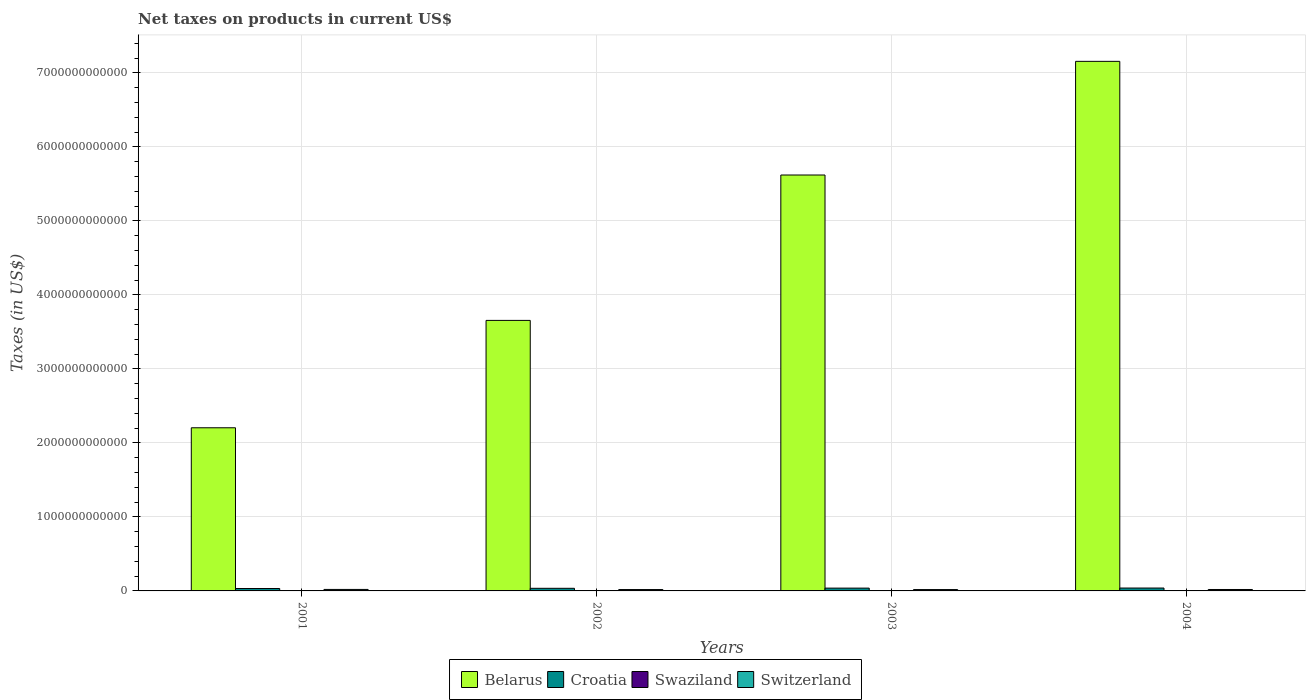How many different coloured bars are there?
Your answer should be compact. 4. Are the number of bars per tick equal to the number of legend labels?
Offer a very short reply. Yes. Are the number of bars on each tick of the X-axis equal?
Your answer should be very brief. Yes. How many bars are there on the 3rd tick from the left?
Keep it short and to the point. 4. In how many cases, is the number of bars for a given year not equal to the number of legend labels?
Ensure brevity in your answer.  0. What is the net taxes on products in Swaziland in 2002?
Provide a short and direct response. 2.25e+09. Across all years, what is the maximum net taxes on products in Belarus?
Your response must be concise. 7.16e+12. Across all years, what is the minimum net taxes on products in Switzerland?
Provide a succinct answer. 1.82e+1. What is the total net taxes on products in Croatia in the graph?
Provide a short and direct response. 1.45e+11. What is the difference between the net taxes on products in Belarus in 2001 and that in 2003?
Offer a terse response. -3.42e+12. What is the difference between the net taxes on products in Switzerland in 2003 and the net taxes on products in Croatia in 2002?
Your answer should be compact. -1.72e+1. What is the average net taxes on products in Swaziland per year?
Your answer should be compact. 2.58e+09. In the year 2003, what is the difference between the net taxes on products in Croatia and net taxes on products in Belarus?
Your answer should be compact. -5.58e+12. What is the ratio of the net taxes on products in Swaziland in 2001 to that in 2004?
Ensure brevity in your answer.  0.6. What is the difference between the highest and the second highest net taxes on products in Croatia?
Keep it short and to the point. 9.82e+08. What is the difference between the highest and the lowest net taxes on products in Swaziland?
Your response must be concise. 1.40e+09. In how many years, is the net taxes on products in Swaziland greater than the average net taxes on products in Swaziland taken over all years?
Provide a short and direct response. 1. Is it the case that in every year, the sum of the net taxes on products in Croatia and net taxes on products in Switzerland is greater than the sum of net taxes on products in Swaziland and net taxes on products in Belarus?
Ensure brevity in your answer.  No. What does the 1st bar from the left in 2001 represents?
Your answer should be very brief. Belarus. What does the 2nd bar from the right in 2003 represents?
Provide a succinct answer. Swaziland. Are all the bars in the graph horizontal?
Your answer should be compact. No. What is the difference between two consecutive major ticks on the Y-axis?
Make the answer very short. 1.00e+12. Are the values on the major ticks of Y-axis written in scientific E-notation?
Make the answer very short. No. Does the graph contain any zero values?
Your response must be concise. No. Does the graph contain grids?
Give a very brief answer. Yes. How many legend labels are there?
Offer a terse response. 4. What is the title of the graph?
Provide a succinct answer. Net taxes on products in current US$. What is the label or title of the X-axis?
Offer a very short reply. Years. What is the label or title of the Y-axis?
Your answer should be very brief. Taxes (in US$). What is the Taxes (in US$) in Belarus in 2001?
Make the answer very short. 2.20e+12. What is the Taxes (in US$) in Croatia in 2001?
Provide a succinct answer. 3.26e+1. What is the Taxes (in US$) of Swaziland in 2001?
Make the answer very short. 2.05e+09. What is the Taxes (in US$) in Switzerland in 2001?
Offer a very short reply. 2.01e+1. What is the Taxes (in US$) in Belarus in 2002?
Make the answer very short. 3.66e+12. What is the Taxes (in US$) of Croatia in 2002?
Your response must be concise. 3.54e+1. What is the Taxes (in US$) in Swaziland in 2002?
Ensure brevity in your answer.  2.25e+09. What is the Taxes (in US$) of Switzerland in 2002?
Offer a terse response. 1.84e+1. What is the Taxes (in US$) in Belarus in 2003?
Give a very brief answer. 5.62e+12. What is the Taxes (in US$) of Croatia in 2003?
Provide a succinct answer. 3.79e+1. What is the Taxes (in US$) in Swaziland in 2003?
Ensure brevity in your answer.  2.55e+09. What is the Taxes (in US$) in Switzerland in 2003?
Your response must be concise. 1.82e+1. What is the Taxes (in US$) in Belarus in 2004?
Offer a terse response. 7.16e+12. What is the Taxes (in US$) of Croatia in 2004?
Offer a very short reply. 3.89e+1. What is the Taxes (in US$) in Swaziland in 2004?
Your response must be concise. 3.45e+09. What is the Taxes (in US$) in Switzerland in 2004?
Provide a succinct answer. 1.92e+1. Across all years, what is the maximum Taxes (in US$) of Belarus?
Ensure brevity in your answer.  7.16e+12. Across all years, what is the maximum Taxes (in US$) in Croatia?
Provide a short and direct response. 3.89e+1. Across all years, what is the maximum Taxes (in US$) of Swaziland?
Your answer should be compact. 3.45e+09. Across all years, what is the maximum Taxes (in US$) of Switzerland?
Give a very brief answer. 2.01e+1. Across all years, what is the minimum Taxes (in US$) of Belarus?
Provide a short and direct response. 2.20e+12. Across all years, what is the minimum Taxes (in US$) of Croatia?
Your answer should be compact. 3.26e+1. Across all years, what is the minimum Taxes (in US$) of Swaziland?
Provide a short and direct response. 2.05e+09. Across all years, what is the minimum Taxes (in US$) in Switzerland?
Provide a short and direct response. 1.82e+1. What is the total Taxes (in US$) in Belarus in the graph?
Keep it short and to the point. 1.86e+13. What is the total Taxes (in US$) in Croatia in the graph?
Your answer should be very brief. 1.45e+11. What is the total Taxes (in US$) in Swaziland in the graph?
Your answer should be very brief. 1.03e+1. What is the total Taxes (in US$) in Switzerland in the graph?
Give a very brief answer. 7.59e+1. What is the difference between the Taxes (in US$) of Belarus in 2001 and that in 2002?
Keep it short and to the point. -1.45e+12. What is the difference between the Taxes (in US$) in Croatia in 2001 and that in 2002?
Offer a very short reply. -2.80e+09. What is the difference between the Taxes (in US$) in Swaziland in 2001 and that in 2002?
Provide a short and direct response. -1.92e+08. What is the difference between the Taxes (in US$) in Switzerland in 2001 and that in 2002?
Provide a short and direct response. 1.69e+09. What is the difference between the Taxes (in US$) of Belarus in 2001 and that in 2003?
Your answer should be compact. -3.42e+12. What is the difference between the Taxes (in US$) of Croatia in 2001 and that in 2003?
Your response must be concise. -5.28e+09. What is the difference between the Taxes (in US$) of Swaziland in 2001 and that in 2003?
Your response must be concise. -4.91e+08. What is the difference between the Taxes (in US$) in Switzerland in 2001 and that in 2003?
Your answer should be very brief. 1.91e+09. What is the difference between the Taxes (in US$) in Belarus in 2001 and that in 2004?
Provide a short and direct response. -4.95e+12. What is the difference between the Taxes (in US$) in Croatia in 2001 and that in 2004?
Keep it short and to the point. -6.26e+09. What is the difference between the Taxes (in US$) in Swaziland in 2001 and that in 2004?
Make the answer very short. -1.40e+09. What is the difference between the Taxes (in US$) of Switzerland in 2001 and that in 2004?
Offer a very short reply. 8.47e+08. What is the difference between the Taxes (in US$) of Belarus in 2002 and that in 2003?
Keep it short and to the point. -1.96e+12. What is the difference between the Taxes (in US$) of Croatia in 2002 and that in 2003?
Offer a very short reply. -2.48e+09. What is the difference between the Taxes (in US$) of Swaziland in 2002 and that in 2003?
Your answer should be very brief. -2.99e+08. What is the difference between the Taxes (in US$) in Switzerland in 2002 and that in 2003?
Make the answer very short. 2.15e+08. What is the difference between the Taxes (in US$) of Belarus in 2002 and that in 2004?
Offer a very short reply. -3.50e+12. What is the difference between the Taxes (in US$) of Croatia in 2002 and that in 2004?
Keep it short and to the point. -3.46e+09. What is the difference between the Taxes (in US$) of Swaziland in 2002 and that in 2004?
Give a very brief answer. -1.21e+09. What is the difference between the Taxes (in US$) in Switzerland in 2002 and that in 2004?
Make the answer very short. -8.44e+08. What is the difference between the Taxes (in US$) of Belarus in 2003 and that in 2004?
Your answer should be compact. -1.54e+12. What is the difference between the Taxes (in US$) in Croatia in 2003 and that in 2004?
Your answer should be very brief. -9.82e+08. What is the difference between the Taxes (in US$) of Swaziland in 2003 and that in 2004?
Your answer should be very brief. -9.07e+08. What is the difference between the Taxes (in US$) of Switzerland in 2003 and that in 2004?
Your answer should be compact. -1.06e+09. What is the difference between the Taxes (in US$) of Belarus in 2001 and the Taxes (in US$) of Croatia in 2002?
Ensure brevity in your answer.  2.17e+12. What is the difference between the Taxes (in US$) in Belarus in 2001 and the Taxes (in US$) in Swaziland in 2002?
Your answer should be very brief. 2.20e+12. What is the difference between the Taxes (in US$) in Belarus in 2001 and the Taxes (in US$) in Switzerland in 2002?
Make the answer very short. 2.19e+12. What is the difference between the Taxes (in US$) of Croatia in 2001 and the Taxes (in US$) of Swaziland in 2002?
Provide a succinct answer. 3.04e+1. What is the difference between the Taxes (in US$) of Croatia in 2001 and the Taxes (in US$) of Switzerland in 2002?
Ensure brevity in your answer.  1.42e+1. What is the difference between the Taxes (in US$) of Swaziland in 2001 and the Taxes (in US$) of Switzerland in 2002?
Offer a terse response. -1.63e+1. What is the difference between the Taxes (in US$) of Belarus in 2001 and the Taxes (in US$) of Croatia in 2003?
Your answer should be very brief. 2.17e+12. What is the difference between the Taxes (in US$) of Belarus in 2001 and the Taxes (in US$) of Swaziland in 2003?
Ensure brevity in your answer.  2.20e+12. What is the difference between the Taxes (in US$) of Belarus in 2001 and the Taxes (in US$) of Switzerland in 2003?
Your answer should be compact. 2.19e+12. What is the difference between the Taxes (in US$) of Croatia in 2001 and the Taxes (in US$) of Swaziland in 2003?
Your response must be concise. 3.01e+1. What is the difference between the Taxes (in US$) of Croatia in 2001 and the Taxes (in US$) of Switzerland in 2003?
Your answer should be very brief. 1.44e+1. What is the difference between the Taxes (in US$) of Swaziland in 2001 and the Taxes (in US$) of Switzerland in 2003?
Give a very brief answer. -1.61e+1. What is the difference between the Taxes (in US$) of Belarus in 2001 and the Taxes (in US$) of Croatia in 2004?
Provide a succinct answer. 2.17e+12. What is the difference between the Taxes (in US$) in Belarus in 2001 and the Taxes (in US$) in Swaziland in 2004?
Provide a succinct answer. 2.20e+12. What is the difference between the Taxes (in US$) of Belarus in 2001 and the Taxes (in US$) of Switzerland in 2004?
Keep it short and to the point. 2.19e+12. What is the difference between the Taxes (in US$) in Croatia in 2001 and the Taxes (in US$) in Swaziland in 2004?
Provide a short and direct response. 2.92e+1. What is the difference between the Taxes (in US$) in Croatia in 2001 and the Taxes (in US$) in Switzerland in 2004?
Offer a very short reply. 1.34e+1. What is the difference between the Taxes (in US$) of Swaziland in 2001 and the Taxes (in US$) of Switzerland in 2004?
Give a very brief answer. -1.72e+1. What is the difference between the Taxes (in US$) in Belarus in 2002 and the Taxes (in US$) in Croatia in 2003?
Provide a short and direct response. 3.62e+12. What is the difference between the Taxes (in US$) of Belarus in 2002 and the Taxes (in US$) of Swaziland in 2003?
Provide a short and direct response. 3.65e+12. What is the difference between the Taxes (in US$) in Belarus in 2002 and the Taxes (in US$) in Switzerland in 2003?
Keep it short and to the point. 3.64e+12. What is the difference between the Taxes (in US$) of Croatia in 2002 and the Taxes (in US$) of Swaziland in 2003?
Make the answer very short. 3.29e+1. What is the difference between the Taxes (in US$) in Croatia in 2002 and the Taxes (in US$) in Switzerland in 2003?
Offer a terse response. 1.72e+1. What is the difference between the Taxes (in US$) in Swaziland in 2002 and the Taxes (in US$) in Switzerland in 2003?
Your answer should be compact. -1.59e+1. What is the difference between the Taxes (in US$) in Belarus in 2002 and the Taxes (in US$) in Croatia in 2004?
Keep it short and to the point. 3.62e+12. What is the difference between the Taxes (in US$) in Belarus in 2002 and the Taxes (in US$) in Swaziland in 2004?
Provide a short and direct response. 3.65e+12. What is the difference between the Taxes (in US$) of Belarus in 2002 and the Taxes (in US$) of Switzerland in 2004?
Make the answer very short. 3.64e+12. What is the difference between the Taxes (in US$) in Croatia in 2002 and the Taxes (in US$) in Swaziland in 2004?
Your answer should be compact. 3.20e+1. What is the difference between the Taxes (in US$) of Croatia in 2002 and the Taxes (in US$) of Switzerland in 2004?
Make the answer very short. 1.62e+1. What is the difference between the Taxes (in US$) of Swaziland in 2002 and the Taxes (in US$) of Switzerland in 2004?
Provide a succinct answer. -1.70e+1. What is the difference between the Taxes (in US$) in Belarus in 2003 and the Taxes (in US$) in Croatia in 2004?
Keep it short and to the point. 5.58e+12. What is the difference between the Taxes (in US$) of Belarus in 2003 and the Taxes (in US$) of Swaziland in 2004?
Keep it short and to the point. 5.62e+12. What is the difference between the Taxes (in US$) of Belarus in 2003 and the Taxes (in US$) of Switzerland in 2004?
Give a very brief answer. 5.60e+12. What is the difference between the Taxes (in US$) of Croatia in 2003 and the Taxes (in US$) of Swaziland in 2004?
Offer a very short reply. 3.44e+1. What is the difference between the Taxes (in US$) of Croatia in 2003 and the Taxes (in US$) of Switzerland in 2004?
Provide a short and direct response. 1.86e+1. What is the difference between the Taxes (in US$) in Swaziland in 2003 and the Taxes (in US$) in Switzerland in 2004?
Your answer should be compact. -1.67e+1. What is the average Taxes (in US$) in Belarus per year?
Your answer should be very brief. 4.66e+12. What is the average Taxes (in US$) of Croatia per year?
Provide a short and direct response. 3.62e+1. What is the average Taxes (in US$) in Swaziland per year?
Your answer should be very brief. 2.58e+09. What is the average Taxes (in US$) of Switzerland per year?
Your response must be concise. 1.90e+1. In the year 2001, what is the difference between the Taxes (in US$) in Belarus and Taxes (in US$) in Croatia?
Offer a terse response. 2.17e+12. In the year 2001, what is the difference between the Taxes (in US$) in Belarus and Taxes (in US$) in Swaziland?
Your response must be concise. 2.20e+12. In the year 2001, what is the difference between the Taxes (in US$) in Belarus and Taxes (in US$) in Switzerland?
Make the answer very short. 2.18e+12. In the year 2001, what is the difference between the Taxes (in US$) of Croatia and Taxes (in US$) of Swaziland?
Your answer should be very brief. 3.06e+1. In the year 2001, what is the difference between the Taxes (in US$) of Croatia and Taxes (in US$) of Switzerland?
Give a very brief answer. 1.25e+1. In the year 2001, what is the difference between the Taxes (in US$) of Swaziland and Taxes (in US$) of Switzerland?
Provide a short and direct response. -1.80e+1. In the year 2002, what is the difference between the Taxes (in US$) of Belarus and Taxes (in US$) of Croatia?
Make the answer very short. 3.62e+12. In the year 2002, what is the difference between the Taxes (in US$) in Belarus and Taxes (in US$) in Swaziland?
Offer a very short reply. 3.65e+12. In the year 2002, what is the difference between the Taxes (in US$) of Belarus and Taxes (in US$) of Switzerland?
Ensure brevity in your answer.  3.64e+12. In the year 2002, what is the difference between the Taxes (in US$) in Croatia and Taxes (in US$) in Swaziland?
Ensure brevity in your answer.  3.32e+1. In the year 2002, what is the difference between the Taxes (in US$) of Croatia and Taxes (in US$) of Switzerland?
Provide a succinct answer. 1.70e+1. In the year 2002, what is the difference between the Taxes (in US$) in Swaziland and Taxes (in US$) in Switzerland?
Your response must be concise. -1.62e+1. In the year 2003, what is the difference between the Taxes (in US$) in Belarus and Taxes (in US$) in Croatia?
Offer a very short reply. 5.58e+12. In the year 2003, what is the difference between the Taxes (in US$) of Belarus and Taxes (in US$) of Swaziland?
Keep it short and to the point. 5.62e+12. In the year 2003, what is the difference between the Taxes (in US$) in Belarus and Taxes (in US$) in Switzerland?
Ensure brevity in your answer.  5.60e+12. In the year 2003, what is the difference between the Taxes (in US$) in Croatia and Taxes (in US$) in Swaziland?
Ensure brevity in your answer.  3.53e+1. In the year 2003, what is the difference between the Taxes (in US$) in Croatia and Taxes (in US$) in Switzerland?
Your response must be concise. 1.97e+1. In the year 2003, what is the difference between the Taxes (in US$) of Swaziland and Taxes (in US$) of Switzerland?
Your answer should be very brief. -1.56e+1. In the year 2004, what is the difference between the Taxes (in US$) in Belarus and Taxes (in US$) in Croatia?
Ensure brevity in your answer.  7.12e+12. In the year 2004, what is the difference between the Taxes (in US$) in Belarus and Taxes (in US$) in Swaziland?
Provide a short and direct response. 7.15e+12. In the year 2004, what is the difference between the Taxes (in US$) of Belarus and Taxes (in US$) of Switzerland?
Your answer should be compact. 7.14e+12. In the year 2004, what is the difference between the Taxes (in US$) in Croatia and Taxes (in US$) in Swaziland?
Give a very brief answer. 3.54e+1. In the year 2004, what is the difference between the Taxes (in US$) in Croatia and Taxes (in US$) in Switzerland?
Offer a terse response. 1.96e+1. In the year 2004, what is the difference between the Taxes (in US$) in Swaziland and Taxes (in US$) in Switzerland?
Offer a very short reply. -1.58e+1. What is the ratio of the Taxes (in US$) in Belarus in 2001 to that in 2002?
Your response must be concise. 0.6. What is the ratio of the Taxes (in US$) in Croatia in 2001 to that in 2002?
Your response must be concise. 0.92. What is the ratio of the Taxes (in US$) in Swaziland in 2001 to that in 2002?
Keep it short and to the point. 0.91. What is the ratio of the Taxes (in US$) in Switzerland in 2001 to that in 2002?
Ensure brevity in your answer.  1.09. What is the ratio of the Taxes (in US$) of Belarus in 2001 to that in 2003?
Your answer should be compact. 0.39. What is the ratio of the Taxes (in US$) of Croatia in 2001 to that in 2003?
Your answer should be compact. 0.86. What is the ratio of the Taxes (in US$) of Swaziland in 2001 to that in 2003?
Make the answer very short. 0.81. What is the ratio of the Taxes (in US$) in Switzerland in 2001 to that in 2003?
Keep it short and to the point. 1.1. What is the ratio of the Taxes (in US$) of Belarus in 2001 to that in 2004?
Your answer should be very brief. 0.31. What is the ratio of the Taxes (in US$) of Croatia in 2001 to that in 2004?
Give a very brief answer. 0.84. What is the ratio of the Taxes (in US$) of Swaziland in 2001 to that in 2004?
Offer a terse response. 0.6. What is the ratio of the Taxes (in US$) in Switzerland in 2001 to that in 2004?
Give a very brief answer. 1.04. What is the ratio of the Taxes (in US$) in Belarus in 2002 to that in 2003?
Offer a very short reply. 0.65. What is the ratio of the Taxes (in US$) in Croatia in 2002 to that in 2003?
Offer a very short reply. 0.93. What is the ratio of the Taxes (in US$) of Swaziland in 2002 to that in 2003?
Offer a very short reply. 0.88. What is the ratio of the Taxes (in US$) in Switzerland in 2002 to that in 2003?
Make the answer very short. 1.01. What is the ratio of the Taxes (in US$) in Belarus in 2002 to that in 2004?
Your answer should be compact. 0.51. What is the ratio of the Taxes (in US$) of Croatia in 2002 to that in 2004?
Ensure brevity in your answer.  0.91. What is the ratio of the Taxes (in US$) of Swaziland in 2002 to that in 2004?
Provide a short and direct response. 0.65. What is the ratio of the Taxes (in US$) in Switzerland in 2002 to that in 2004?
Your answer should be very brief. 0.96. What is the ratio of the Taxes (in US$) in Belarus in 2003 to that in 2004?
Your response must be concise. 0.79. What is the ratio of the Taxes (in US$) of Croatia in 2003 to that in 2004?
Offer a very short reply. 0.97. What is the ratio of the Taxes (in US$) in Swaziland in 2003 to that in 2004?
Offer a very short reply. 0.74. What is the ratio of the Taxes (in US$) in Switzerland in 2003 to that in 2004?
Provide a succinct answer. 0.94. What is the difference between the highest and the second highest Taxes (in US$) of Belarus?
Offer a terse response. 1.54e+12. What is the difference between the highest and the second highest Taxes (in US$) of Croatia?
Your answer should be compact. 9.82e+08. What is the difference between the highest and the second highest Taxes (in US$) of Swaziland?
Ensure brevity in your answer.  9.07e+08. What is the difference between the highest and the second highest Taxes (in US$) in Switzerland?
Keep it short and to the point. 8.47e+08. What is the difference between the highest and the lowest Taxes (in US$) of Belarus?
Keep it short and to the point. 4.95e+12. What is the difference between the highest and the lowest Taxes (in US$) in Croatia?
Ensure brevity in your answer.  6.26e+09. What is the difference between the highest and the lowest Taxes (in US$) of Swaziland?
Your answer should be compact. 1.40e+09. What is the difference between the highest and the lowest Taxes (in US$) in Switzerland?
Your answer should be compact. 1.91e+09. 